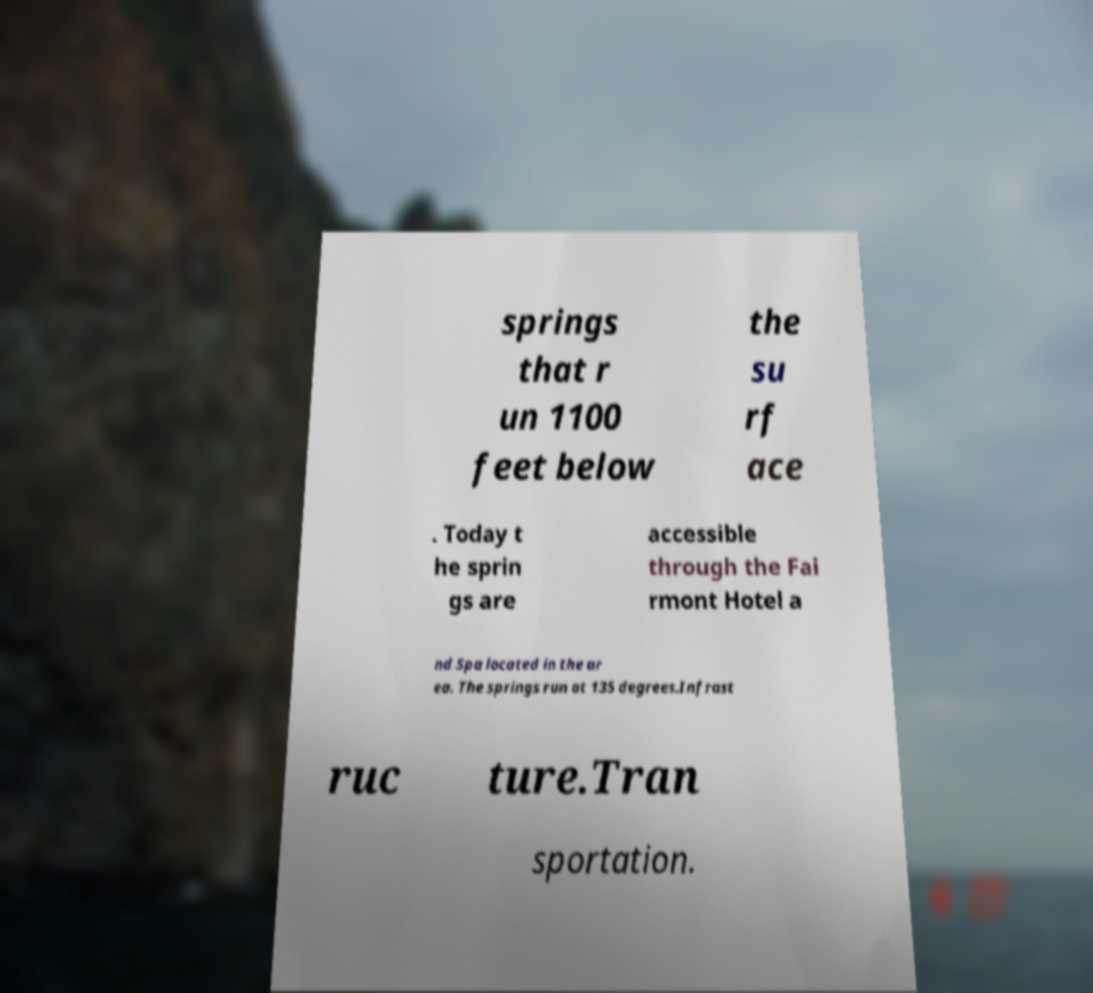Could you assist in decoding the text presented in this image and type it out clearly? springs that r un 1100 feet below the su rf ace . Today t he sprin gs are accessible through the Fai rmont Hotel a nd Spa located in the ar ea. The springs run at 135 degrees.Infrast ruc ture.Tran sportation. 